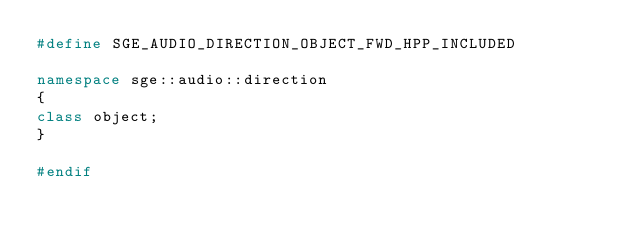Convert code to text. <code><loc_0><loc_0><loc_500><loc_500><_C++_>#define SGE_AUDIO_DIRECTION_OBJECT_FWD_HPP_INCLUDED

namespace sge::audio::direction
{
class object;
}

#endif
</code> 